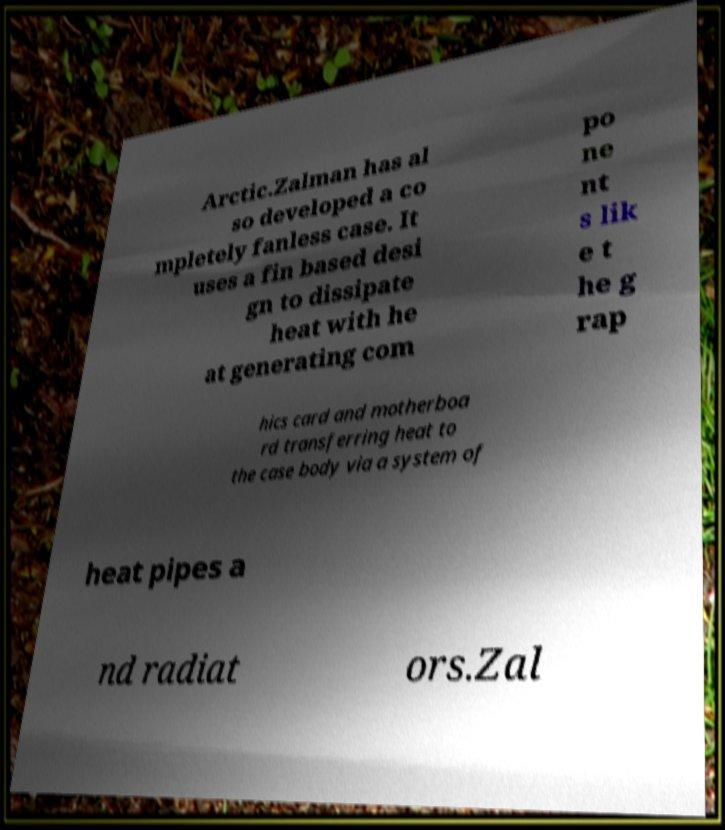There's text embedded in this image that I need extracted. Can you transcribe it verbatim? Arctic.Zalman has al so developed a co mpletely fanless case. It uses a fin based desi gn to dissipate heat with he at generating com po ne nt s lik e t he g rap hics card and motherboa rd transferring heat to the case body via a system of heat pipes a nd radiat ors.Zal 